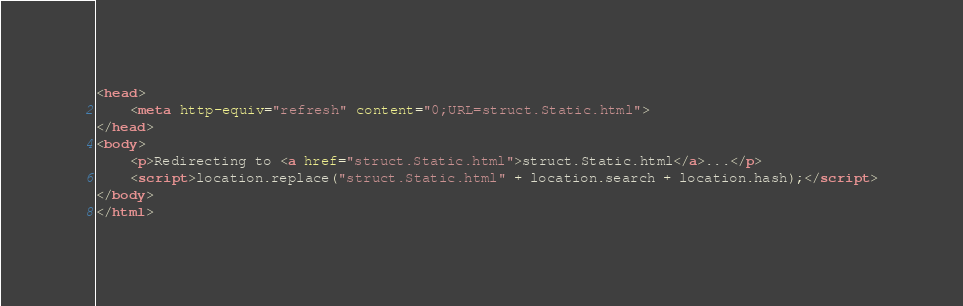<code> <loc_0><loc_0><loc_500><loc_500><_HTML_><head>
    <meta http-equiv="refresh" content="0;URL=struct.Static.html">
</head>
<body>
    <p>Redirecting to <a href="struct.Static.html">struct.Static.html</a>...</p>
    <script>location.replace("struct.Static.html" + location.search + location.hash);</script>
</body>
</html></code> 